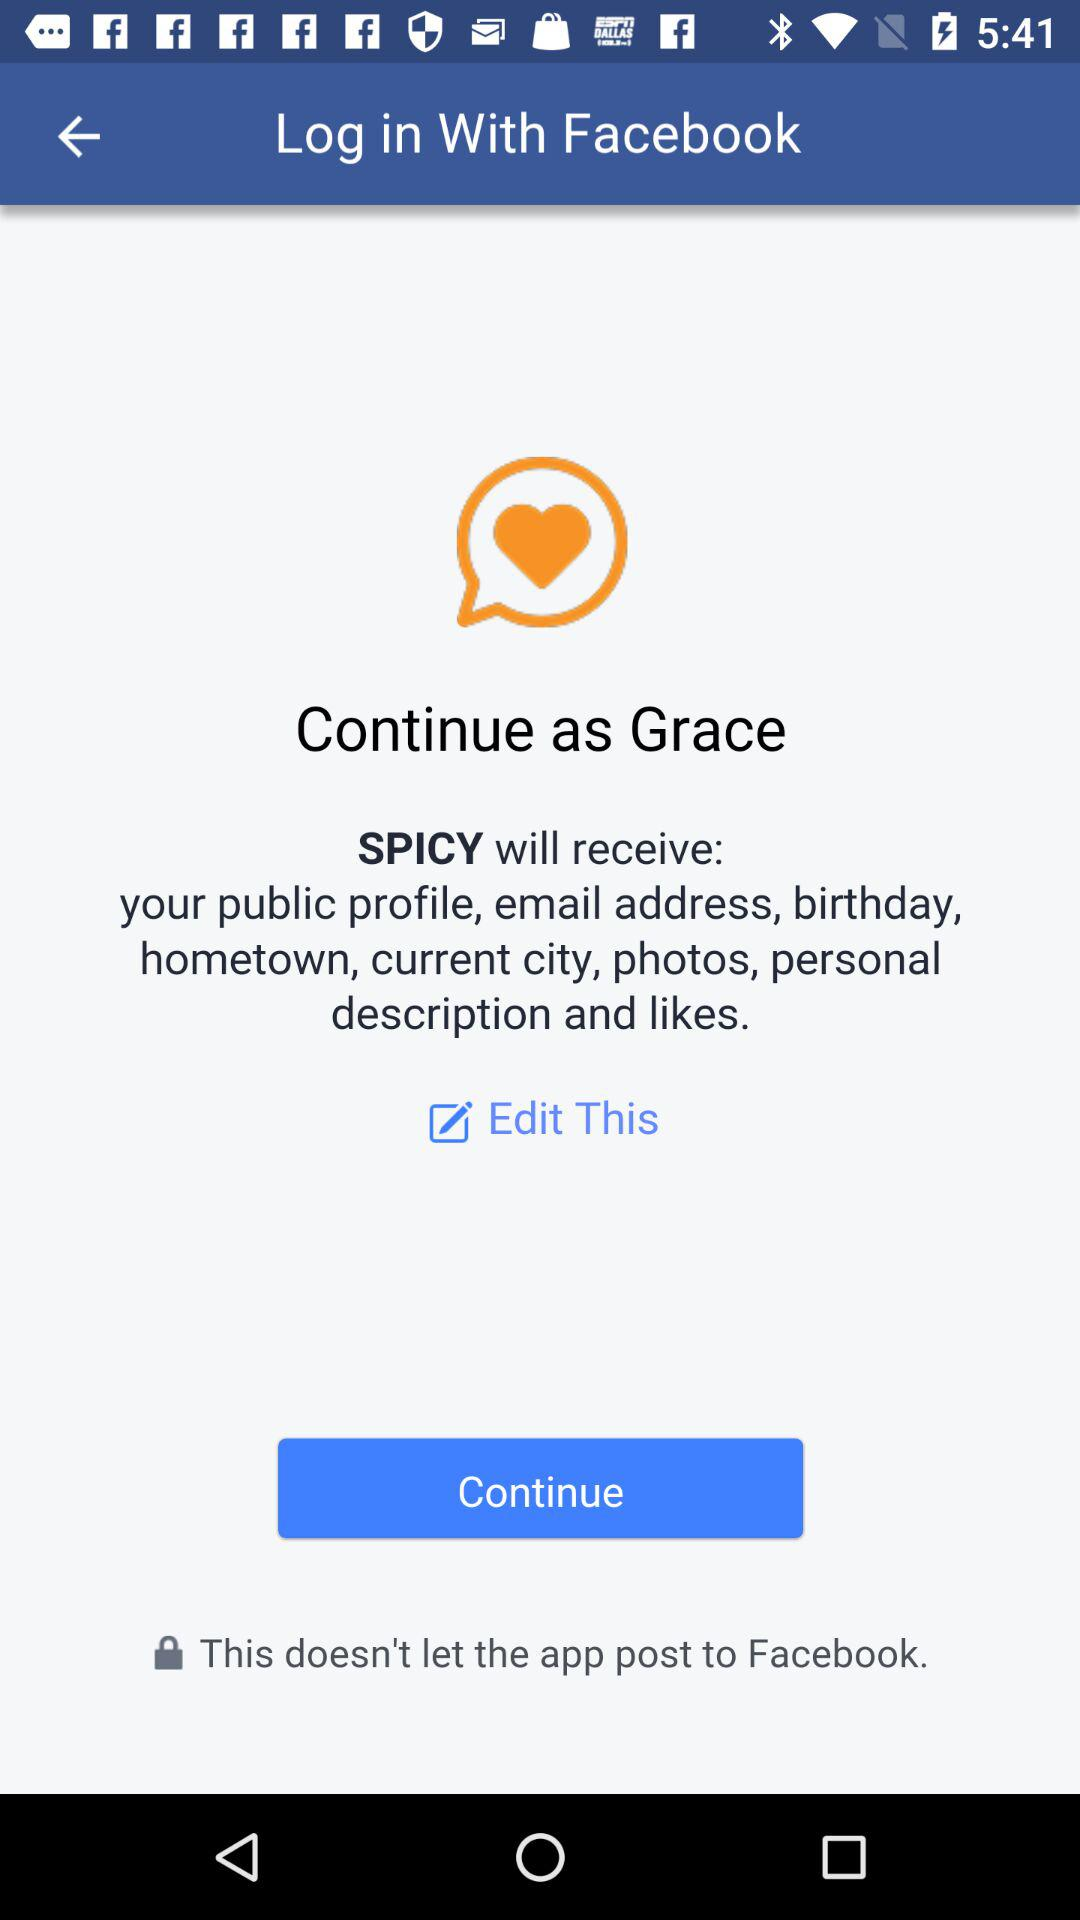What is the user name? The user name is Grace. 